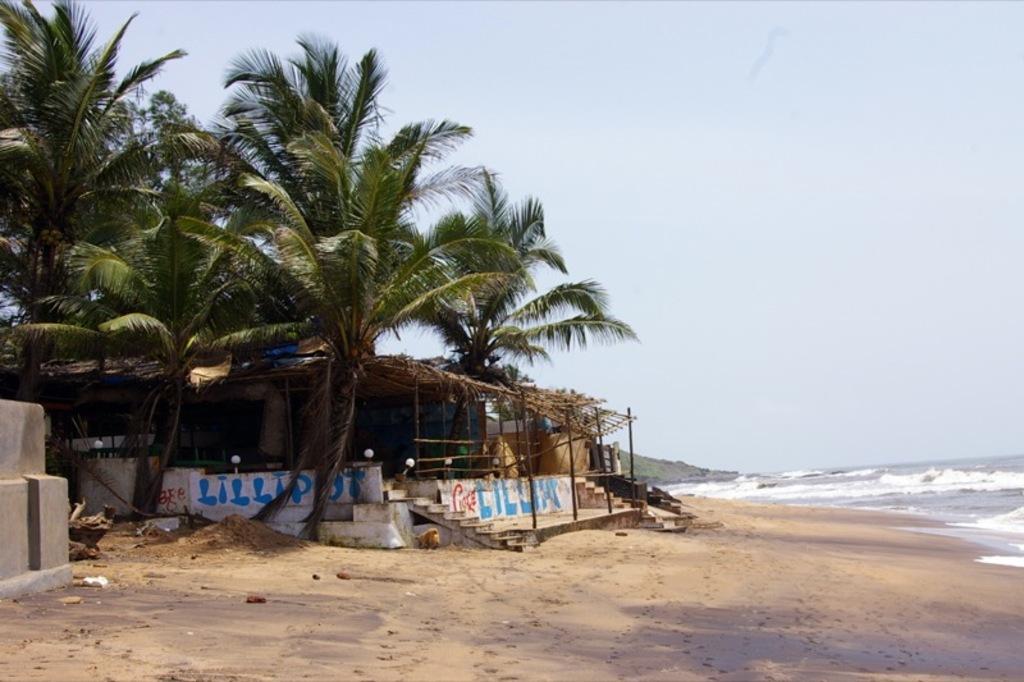In one or two sentences, can you explain what this image depicts? In the image there is a beach and in front of the beach there is a but, there are many coconut trees around that hurt. 